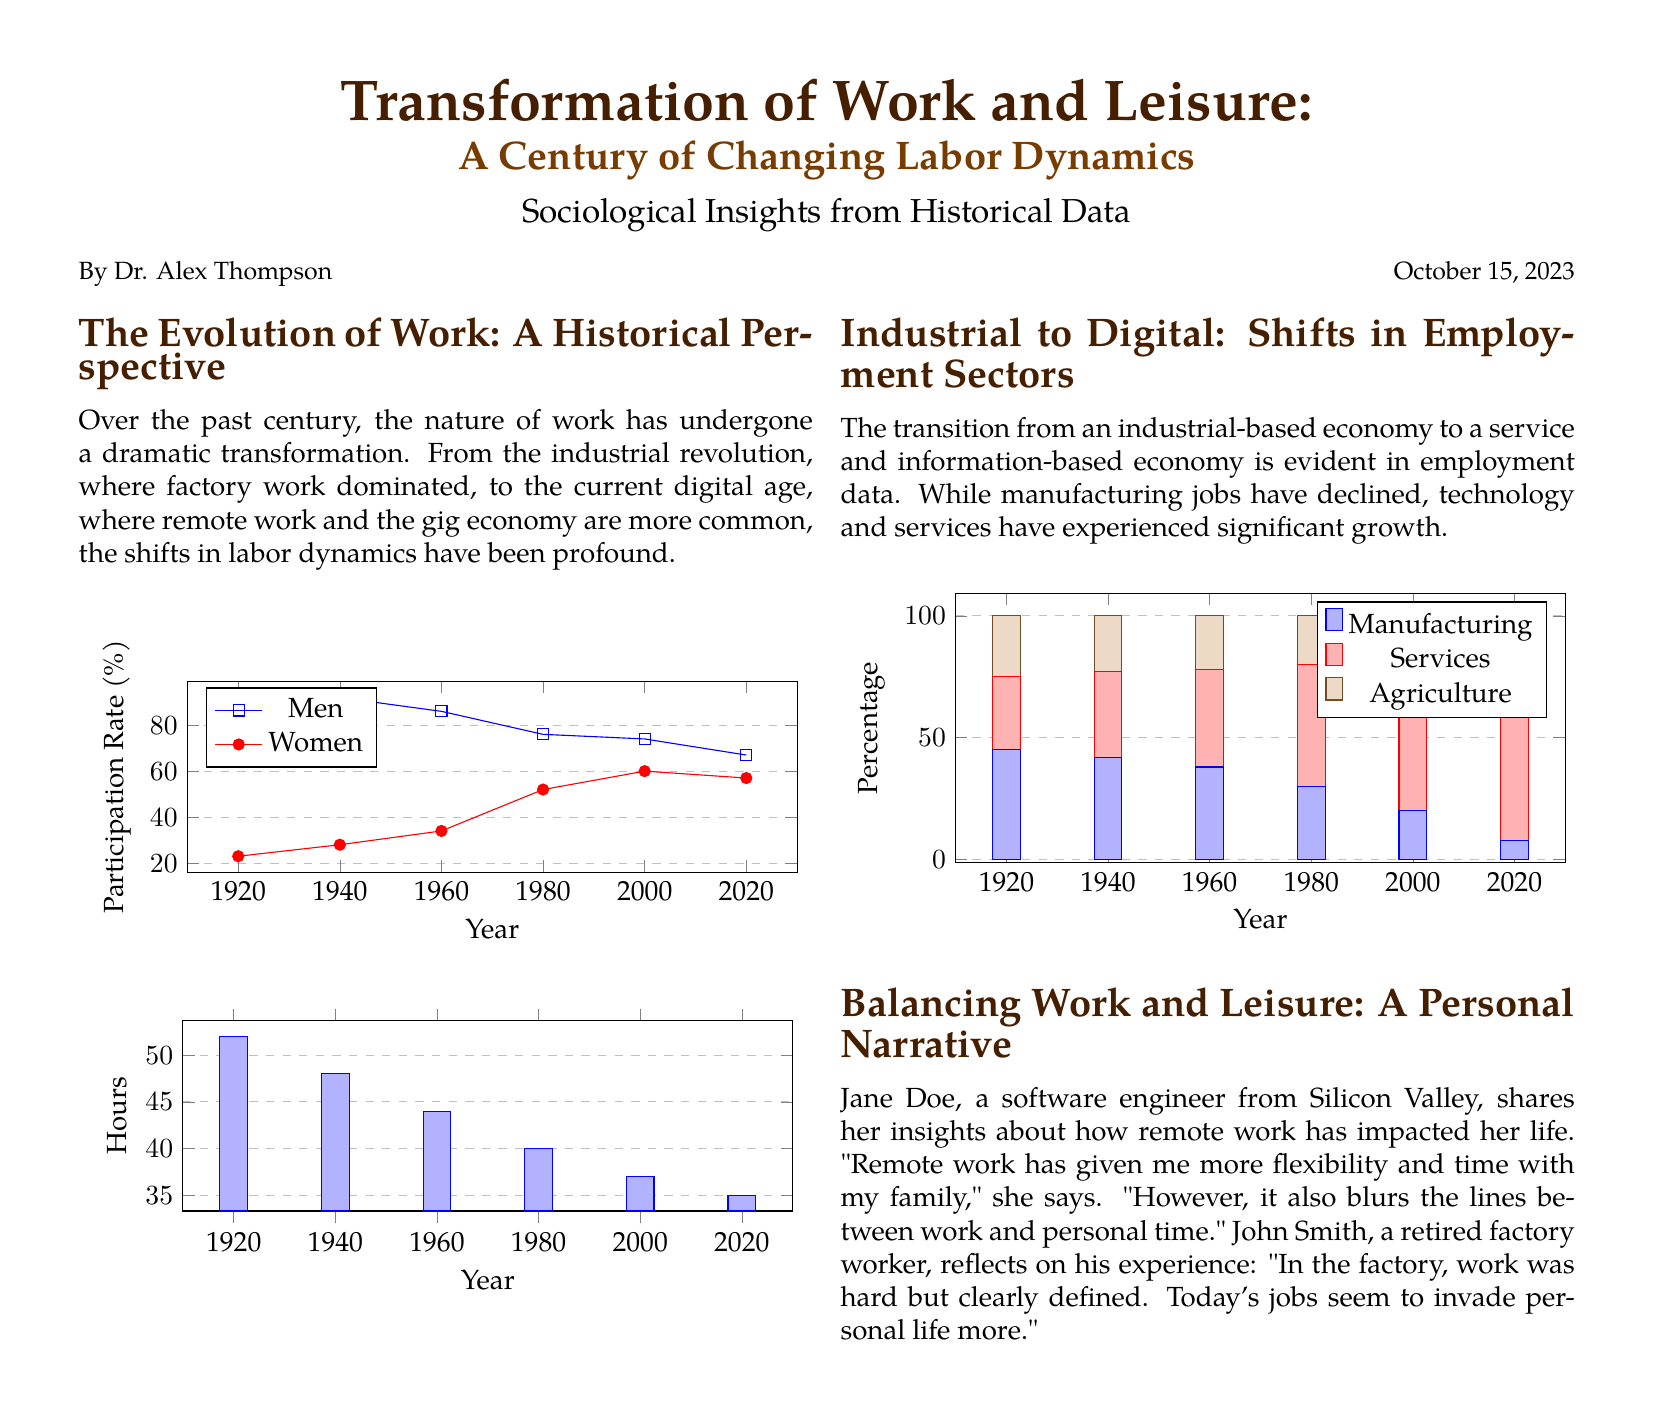What is the main topic of the document? The main topic of the document focuses on the transformation of work and leisure over the past century.
Answer: Transformation of Work and Leisure Who is the author of this document? The author is mentioned at the end of the document.
Answer: Dr. Alex Thompson In 2020, what was the participation rate for men? The participation rate is represented in a graph showing the rates for men and women over the years.
Answer: 67 Which sector experienced significant growth according to the employment data? The document discusses shifts in employment sectors, highlighting the growth of certain sectors.
Answer: Technology and Services What year had the lowest participation rate for women? The participation rates are listed for various years, showing trends.
Answer: 2020 What personal impact does Jane Doe mention about remote work? Jane Doe provides personal insights reflecting on her experiences with remote work.
Answer: Flexibility In what year did manufacturing employment reach its lowest percentage? The document includes data about employment sectors, including manufacturing percentages.
Answer: 2020 Who shares reflections on their experience in the factory? The document includes personal narratives about work experiences from different individuals.
Answer: John Smith What was the average number of hours worked in 1920? The document contains a graph illustrating the hours worked over the years.
Answer: 52 